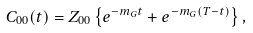Convert formula to latex. <formula><loc_0><loc_0><loc_500><loc_500>C _ { 0 0 } ( t ) = Z _ { 0 0 } \left \{ e ^ { - m _ { G } t } + e ^ { - m _ { G } ( T - t ) } \right \} ,</formula> 